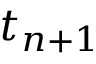<formula> <loc_0><loc_0><loc_500><loc_500>t _ { n + 1 }</formula> 